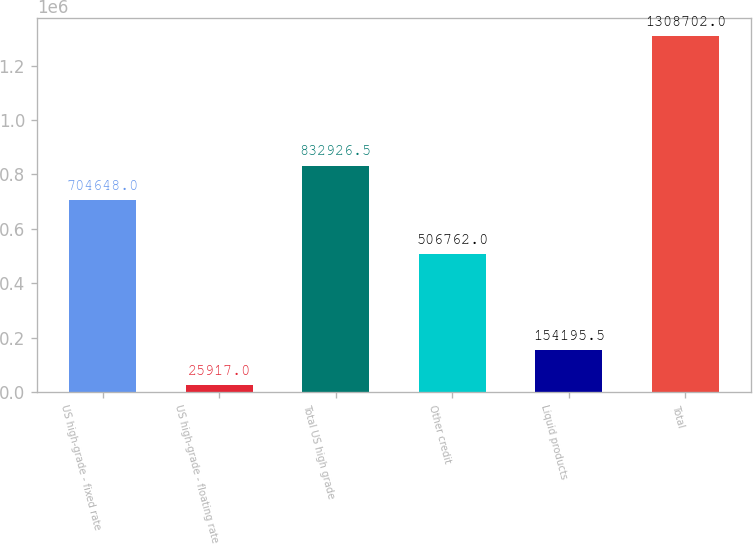<chart> <loc_0><loc_0><loc_500><loc_500><bar_chart><fcel>US high-grade - fixed rate<fcel>US high-grade - floating rate<fcel>Total US high grade<fcel>Other credit<fcel>Liquid products<fcel>Total<nl><fcel>704648<fcel>25917<fcel>832926<fcel>506762<fcel>154196<fcel>1.3087e+06<nl></chart> 